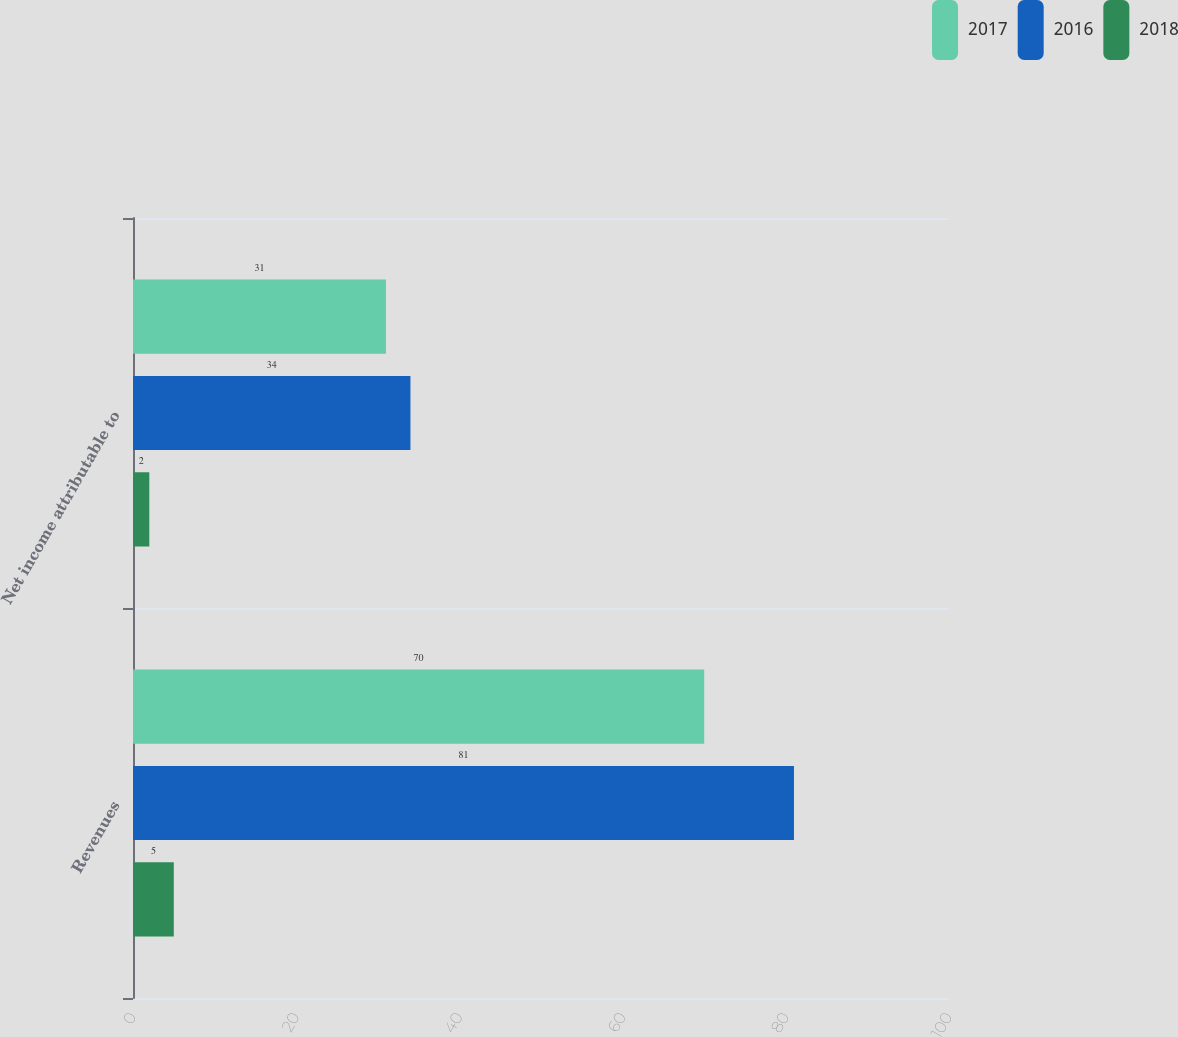<chart> <loc_0><loc_0><loc_500><loc_500><stacked_bar_chart><ecel><fcel>Revenues<fcel>Net income attributable to<nl><fcel>2017<fcel>70<fcel>31<nl><fcel>2016<fcel>81<fcel>34<nl><fcel>2018<fcel>5<fcel>2<nl></chart> 